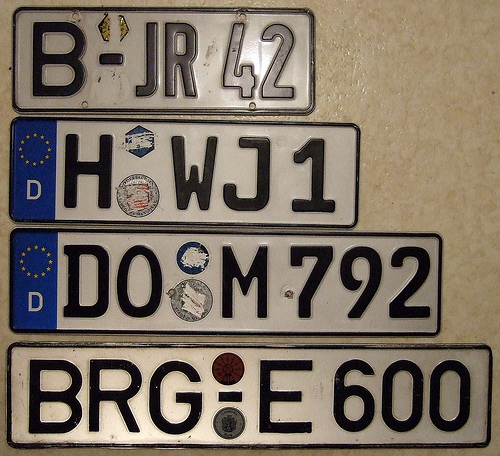<image>
Can you confirm if the number one is in front of the letter w? No. The number one is not in front of the letter w. The spatial positioning shows a different relationship between these objects. 